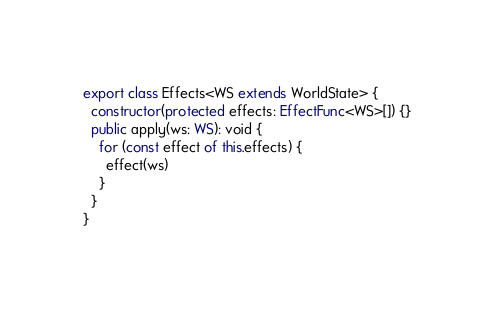<code> <loc_0><loc_0><loc_500><loc_500><_TypeScript_>
export class Effects<WS extends WorldState> {
  constructor(protected effects: EffectFunc<WS>[]) {}
  public apply(ws: WS): void {
    for (const effect of this.effects) {
      effect(ws)
    }
  }
}
</code> 